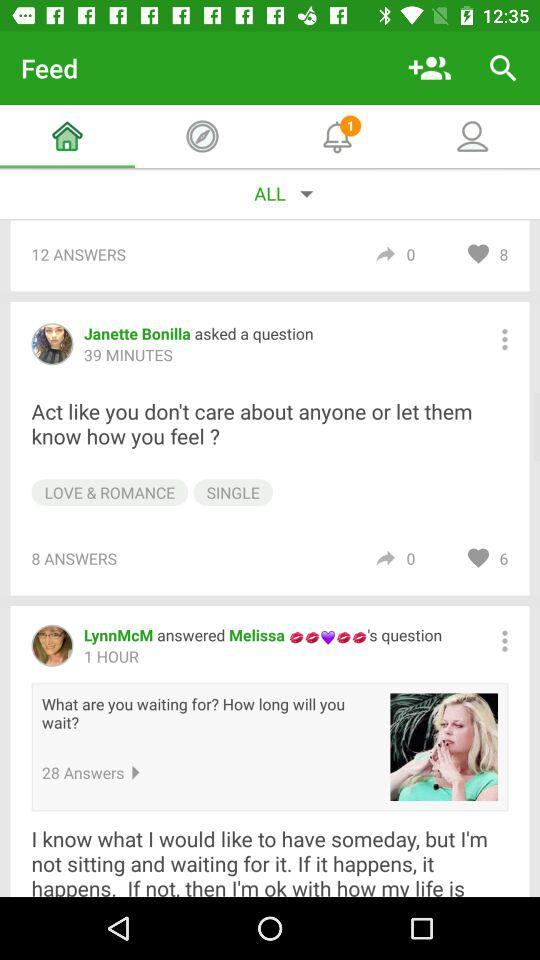How many more hearts does the answer with 6 hearts have than the answer with 0 hearts?
Answer the question using a single word or phrase. 6 